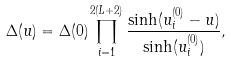<formula> <loc_0><loc_0><loc_500><loc_500>\Delta ( u ) = \Delta ( 0 ) \prod _ { i = 1 } ^ { 2 ( L + 2 ) } \frac { \sinh ( u _ { i } ^ { ( 0 ) } - u ) } { \sinh ( u _ { i } ^ { ( 0 ) } ) } ,</formula> 